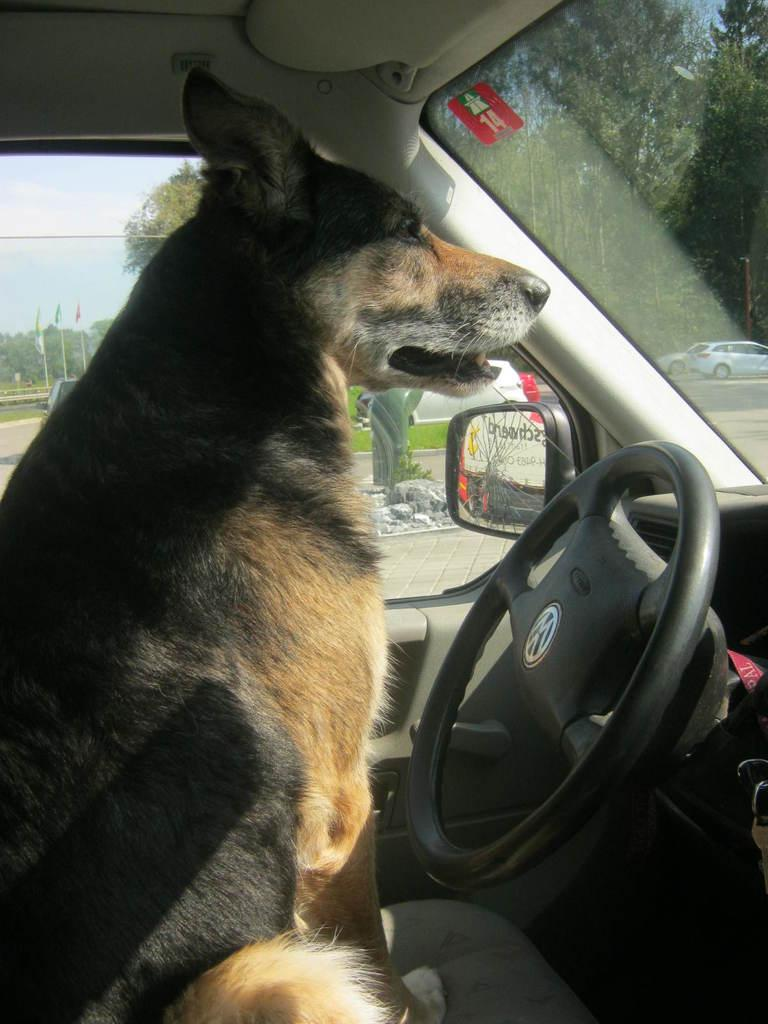What animal is present in the image? There is a dog in the image. Where is the dog located? The dog is in a car. How many rings are the dog wearing in the image? There are no rings visible on the dog in the image. 